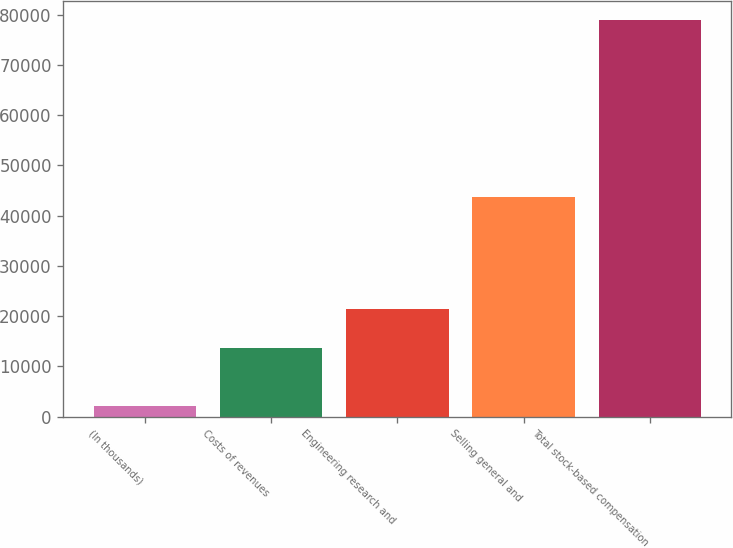Convert chart. <chart><loc_0><loc_0><loc_500><loc_500><bar_chart><fcel>(In thousands)<fcel>Costs of revenues<fcel>Engineering research and<fcel>Selling general and<fcel>Total stock-based compensation<nl><fcel>2012<fcel>13710<fcel>21505<fcel>43620<fcel>78835<nl></chart> 